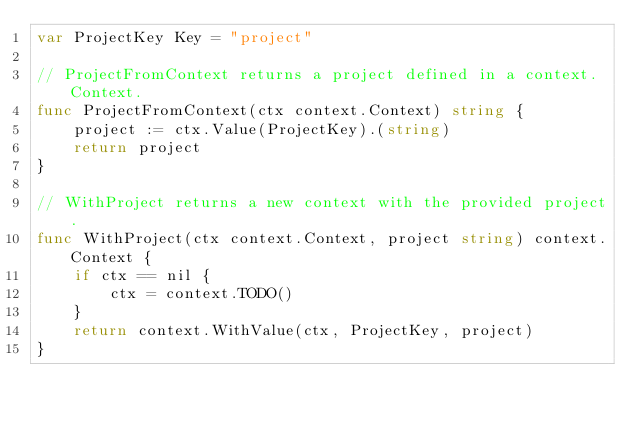<code> <loc_0><loc_0><loc_500><loc_500><_Go_>var ProjectKey Key = "project"

// ProjectFromContext returns a project defined in a context.Context.
func ProjectFromContext(ctx context.Context) string {
	project := ctx.Value(ProjectKey).(string)
	return project
}

// WithProject returns a new context with the provided project.
func WithProject(ctx context.Context, project string) context.Context {
	if ctx == nil {
		ctx = context.TODO()
	}
	return context.WithValue(ctx, ProjectKey, project)
}
</code> 